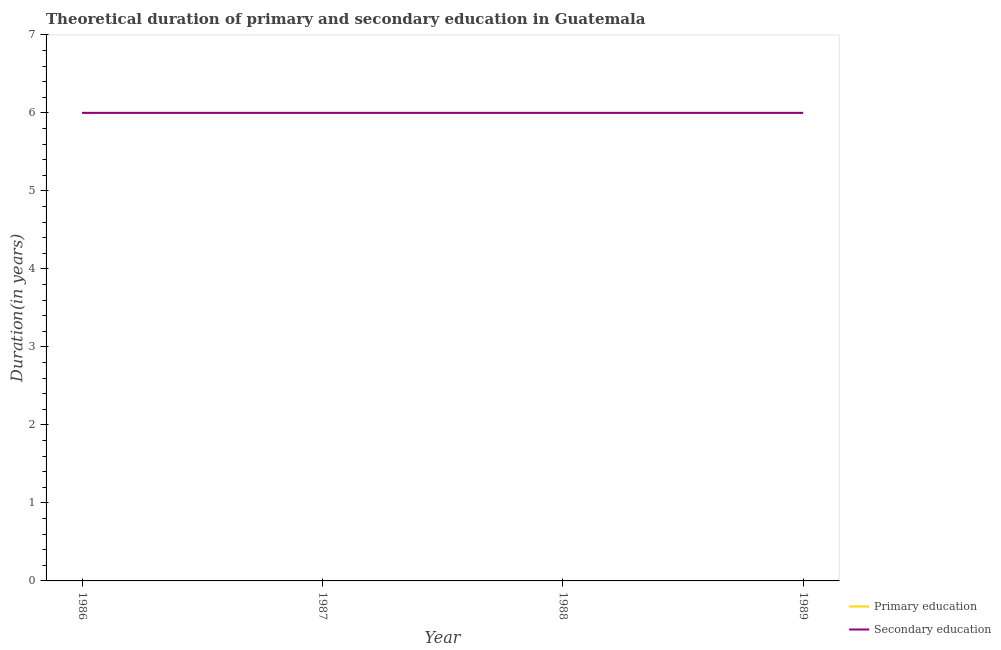Across all years, what is the maximum duration of primary education?
Your answer should be very brief. 6. Across all years, what is the minimum duration of primary education?
Your answer should be compact. 6. In which year was the duration of secondary education maximum?
Your answer should be compact. 1986. In which year was the duration of primary education minimum?
Your answer should be compact. 1986. What is the total duration of primary education in the graph?
Make the answer very short. 24. What is the difference between the duration of secondary education in 1987 and that in 1989?
Offer a very short reply. 0. What is the average duration of primary education per year?
Give a very brief answer. 6. In how many years, is the duration of secondary education greater than 0.8 years?
Offer a very short reply. 4. Is the difference between the duration of secondary education in 1987 and 1989 greater than the difference between the duration of primary education in 1987 and 1989?
Provide a succinct answer. No. What is the difference between the highest and the lowest duration of secondary education?
Offer a very short reply. 0. Does the duration of primary education monotonically increase over the years?
Provide a succinct answer. No. Is the duration of secondary education strictly less than the duration of primary education over the years?
Ensure brevity in your answer.  No. What is the difference between two consecutive major ticks on the Y-axis?
Make the answer very short. 1. Are the values on the major ticks of Y-axis written in scientific E-notation?
Make the answer very short. No. Where does the legend appear in the graph?
Your response must be concise. Bottom right. How are the legend labels stacked?
Offer a very short reply. Vertical. What is the title of the graph?
Offer a terse response. Theoretical duration of primary and secondary education in Guatemala. What is the label or title of the X-axis?
Give a very brief answer. Year. What is the label or title of the Y-axis?
Provide a short and direct response. Duration(in years). What is the Duration(in years) in Primary education in 1987?
Offer a very short reply. 6. What is the Duration(in years) of Secondary education in 1987?
Give a very brief answer. 6. What is the Duration(in years) of Primary education in 1988?
Give a very brief answer. 6. What is the Duration(in years) of Secondary education in 1988?
Make the answer very short. 6. What is the Duration(in years) in Secondary education in 1989?
Make the answer very short. 6. Across all years, what is the maximum Duration(in years) in Primary education?
Offer a terse response. 6. Across all years, what is the maximum Duration(in years) of Secondary education?
Keep it short and to the point. 6. Across all years, what is the minimum Duration(in years) of Primary education?
Make the answer very short. 6. What is the total Duration(in years) of Secondary education in the graph?
Your response must be concise. 24. What is the difference between the Duration(in years) in Primary education in 1986 and that in 1988?
Offer a very short reply. 0. What is the difference between the Duration(in years) of Primary education in 1986 and that in 1989?
Provide a succinct answer. 0. What is the difference between the Duration(in years) in Secondary education in 1987 and that in 1988?
Offer a very short reply. 0. What is the difference between the Duration(in years) of Secondary education in 1987 and that in 1989?
Your response must be concise. 0. What is the difference between the Duration(in years) in Primary education in 1988 and that in 1989?
Make the answer very short. 0. What is the difference between the Duration(in years) of Primary education in 1986 and the Duration(in years) of Secondary education in 1987?
Ensure brevity in your answer.  0. What is the difference between the Duration(in years) of Primary education in 1986 and the Duration(in years) of Secondary education in 1989?
Your answer should be compact. 0. What is the difference between the Duration(in years) of Primary education in 1987 and the Duration(in years) of Secondary education in 1988?
Give a very brief answer. 0. What is the difference between the Duration(in years) in Primary education in 1988 and the Duration(in years) in Secondary education in 1989?
Your answer should be very brief. 0. What is the average Duration(in years) of Primary education per year?
Provide a short and direct response. 6. What is the average Duration(in years) of Secondary education per year?
Ensure brevity in your answer.  6. In the year 1989, what is the difference between the Duration(in years) of Primary education and Duration(in years) of Secondary education?
Offer a terse response. 0. What is the ratio of the Duration(in years) of Primary education in 1986 to that in 1987?
Ensure brevity in your answer.  1. What is the ratio of the Duration(in years) of Secondary education in 1986 to that in 1987?
Your answer should be compact. 1. What is the ratio of the Duration(in years) in Secondary education in 1986 to that in 1988?
Your answer should be compact. 1. What is the ratio of the Duration(in years) in Primary education in 1986 to that in 1989?
Provide a succinct answer. 1. What is the ratio of the Duration(in years) of Secondary education in 1986 to that in 1989?
Your response must be concise. 1. What is the ratio of the Duration(in years) of Primary education in 1987 to that in 1988?
Offer a very short reply. 1. What is the ratio of the Duration(in years) in Primary education in 1988 to that in 1989?
Give a very brief answer. 1. What is the ratio of the Duration(in years) of Secondary education in 1988 to that in 1989?
Give a very brief answer. 1. What is the difference between the highest and the lowest Duration(in years) of Primary education?
Keep it short and to the point. 0. What is the difference between the highest and the lowest Duration(in years) of Secondary education?
Provide a succinct answer. 0. 